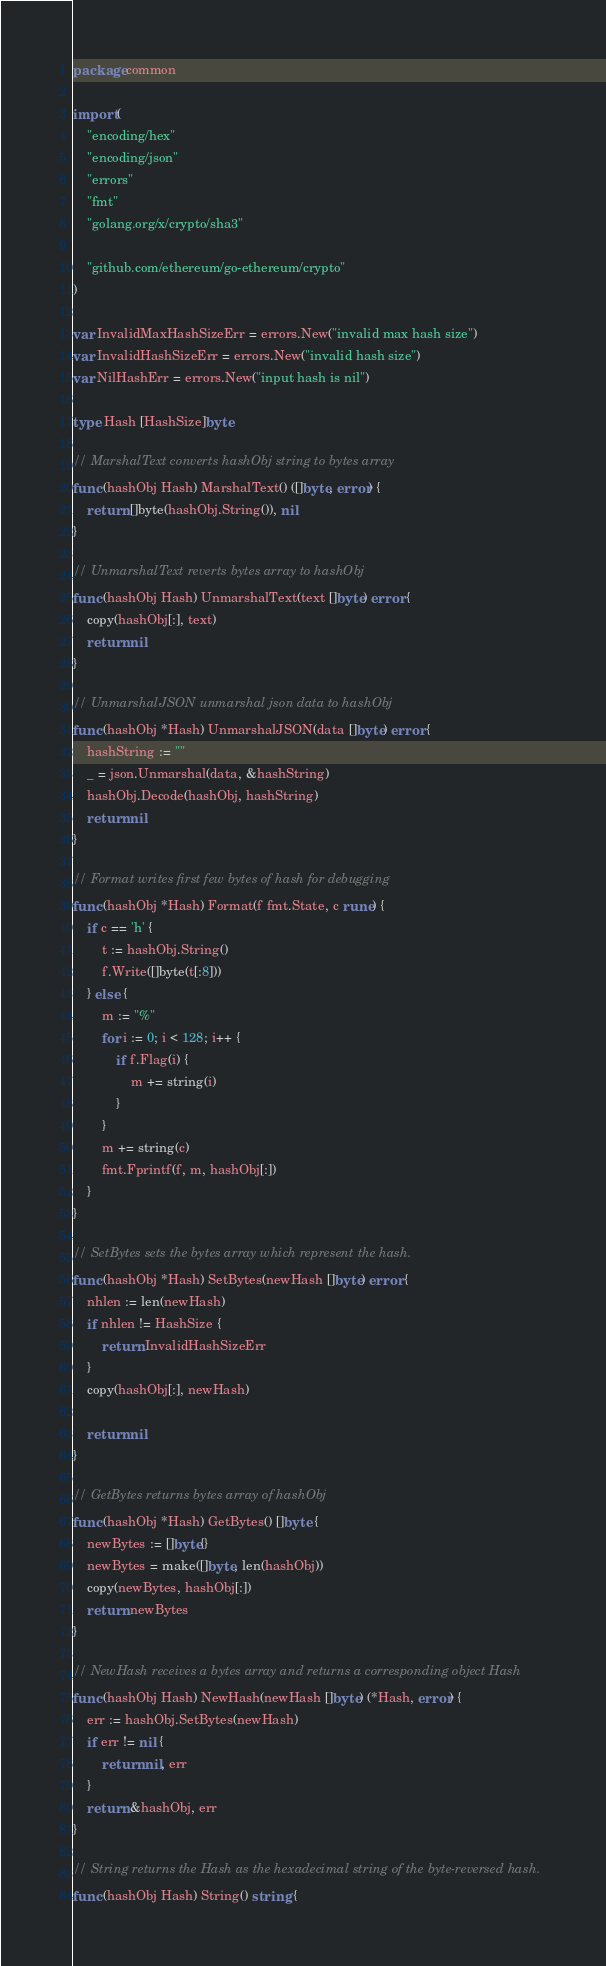<code> <loc_0><loc_0><loc_500><loc_500><_Go_>package common

import (
	"encoding/hex"
	"encoding/json"
	"errors"
	"fmt"
	"golang.org/x/crypto/sha3"

	"github.com/ethereum/go-ethereum/crypto"
)

var InvalidMaxHashSizeErr = errors.New("invalid max hash size")
var InvalidHashSizeErr = errors.New("invalid hash size")
var NilHashErr = errors.New("input hash is nil")

type Hash [HashSize]byte

// MarshalText converts hashObj string to bytes array
func (hashObj Hash) MarshalText() ([]byte, error) {
	return []byte(hashObj.String()), nil
}

// UnmarshalText reverts bytes array to hashObj
func (hashObj Hash) UnmarshalText(text []byte) error {
	copy(hashObj[:], text)
	return nil
}

// UnmarshalJSON unmarshal json data to hashObj
func (hashObj *Hash) UnmarshalJSON(data []byte) error {
	hashString := ""
	_ = json.Unmarshal(data, &hashString)
	hashObj.Decode(hashObj, hashString)
	return nil
}

// Format writes first few bytes of hash for debugging
func (hashObj *Hash) Format(f fmt.State, c rune) {
	if c == 'h' {
		t := hashObj.String()
		f.Write([]byte(t[:8]))
	} else {
		m := "%"
		for i := 0; i < 128; i++ {
			if f.Flag(i) {
				m += string(i)
			}
		}
		m += string(c)
		fmt.Fprintf(f, m, hashObj[:])
	}
}

// SetBytes sets the bytes array which represent the hash.
func (hashObj *Hash) SetBytes(newHash []byte) error {
	nhlen := len(newHash)
	if nhlen != HashSize {
		return InvalidHashSizeErr
	}
	copy(hashObj[:], newHash)

	return nil
}

// GetBytes returns bytes array of hashObj
func (hashObj *Hash) GetBytes() []byte {
	newBytes := []byte{}
	newBytes = make([]byte, len(hashObj))
	copy(newBytes, hashObj[:])
	return newBytes
}

// NewHash receives a bytes array and returns a corresponding object Hash
func (hashObj Hash) NewHash(newHash []byte) (*Hash, error) {
	err := hashObj.SetBytes(newHash)
	if err != nil {
		return nil, err
	}
	return &hashObj, err
}

// String returns the Hash as the hexadecimal string of the byte-reversed hash.
func (hashObj Hash) String() string {</code> 